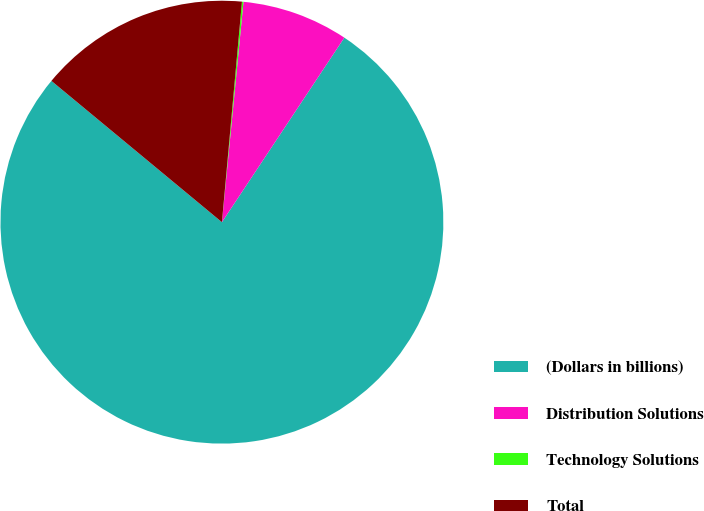<chart> <loc_0><loc_0><loc_500><loc_500><pie_chart><fcel>(Dollars in billions)<fcel>Distribution Solutions<fcel>Technology Solutions<fcel>Total<nl><fcel>76.69%<fcel>7.77%<fcel>0.11%<fcel>15.43%<nl></chart> 